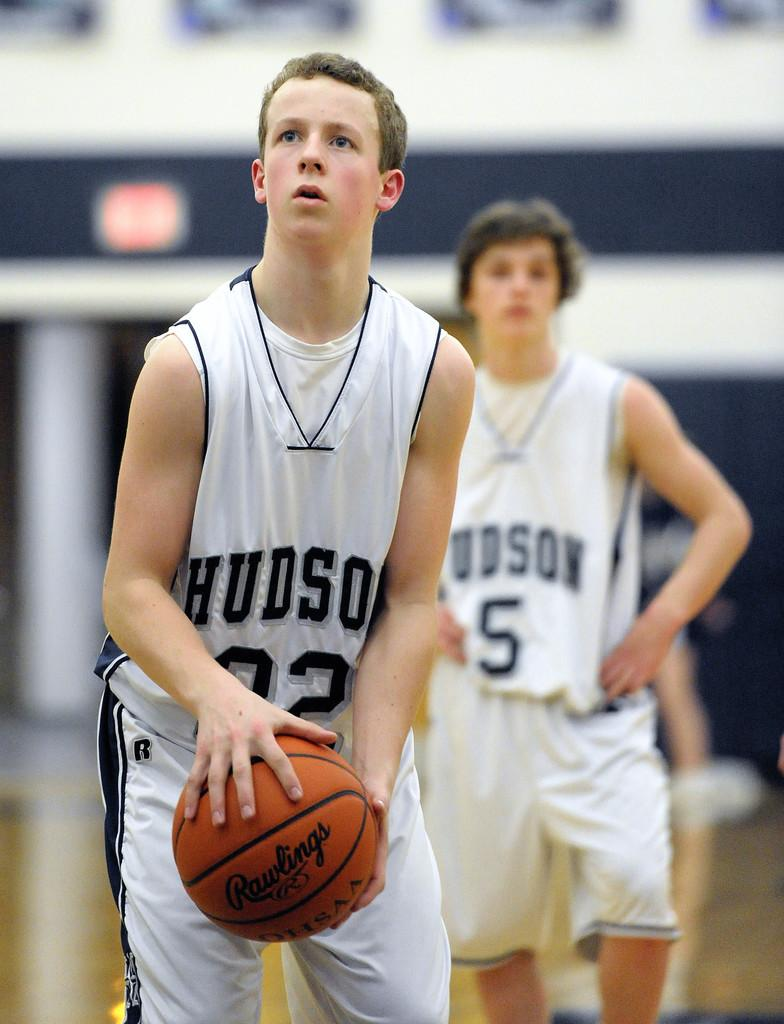Provide a one-sentence caption for the provided image. A young man in a Hudson jersey and a number 02 is holding a basketball. 